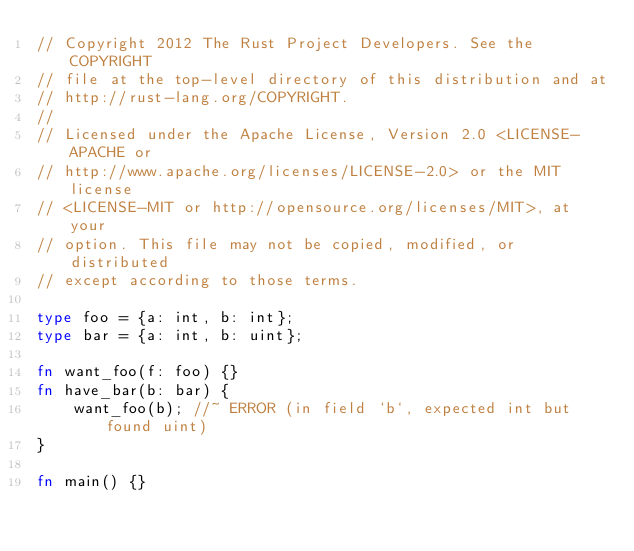<code> <loc_0><loc_0><loc_500><loc_500><_Rust_>// Copyright 2012 The Rust Project Developers. See the COPYRIGHT
// file at the top-level directory of this distribution and at
// http://rust-lang.org/COPYRIGHT.
//
// Licensed under the Apache License, Version 2.0 <LICENSE-APACHE or
// http://www.apache.org/licenses/LICENSE-2.0> or the MIT license
// <LICENSE-MIT or http://opensource.org/licenses/MIT>, at your
// option. This file may not be copied, modified, or distributed
// except according to those terms.

type foo = {a: int, b: int};
type bar = {a: int, b: uint};

fn want_foo(f: foo) {}
fn have_bar(b: bar) {
    want_foo(b); //~ ERROR (in field `b`, expected int but found uint)
}

fn main() {}
</code> 